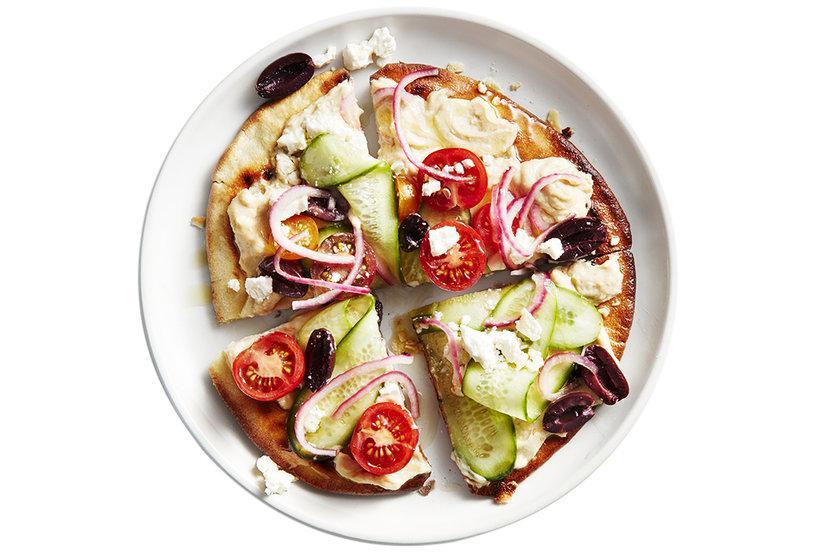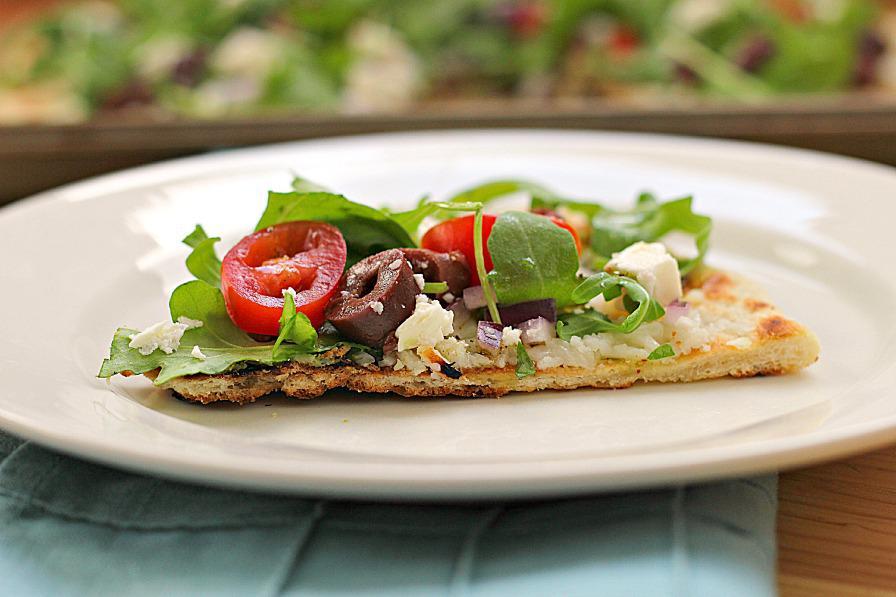The first image is the image on the left, the second image is the image on the right. For the images shown, is this caption "The left and right image contains the same number of circle shaped pizzas." true? Answer yes or no. No. The first image is the image on the left, the second image is the image on the right. For the images shown, is this caption "The left image contains a round pizza cut in four parts, with a yellowish pepper on top of each slice." true? Answer yes or no. No. 